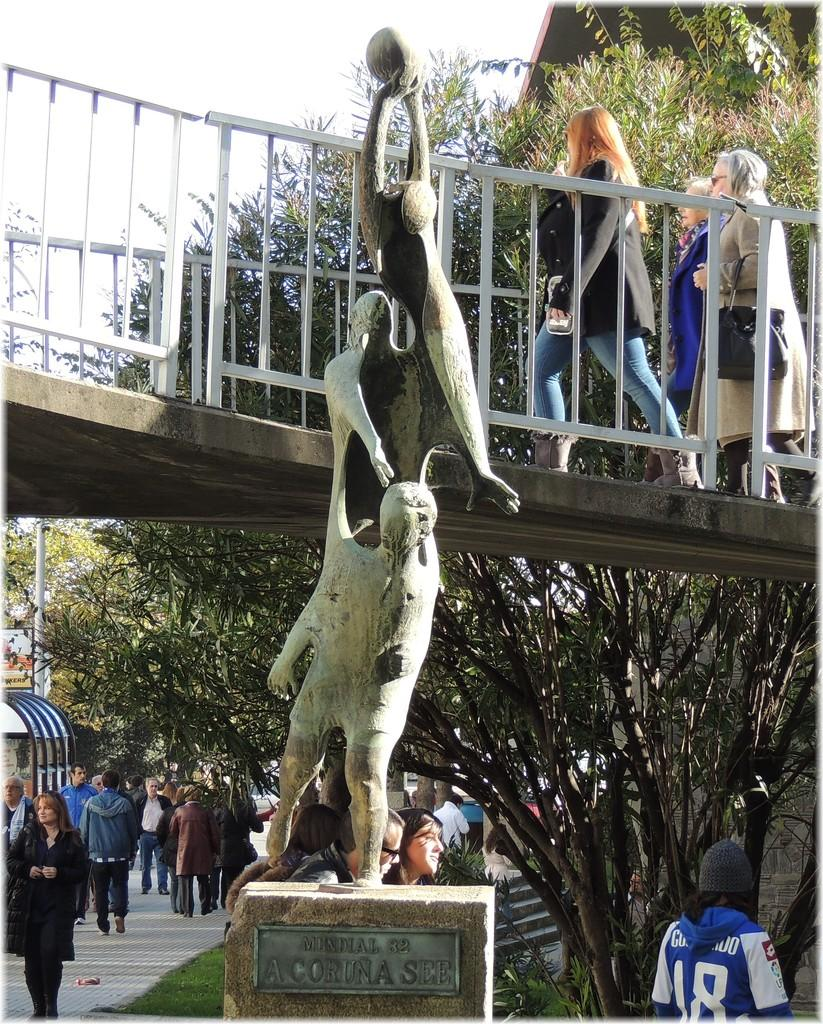<image>
Give a short and clear explanation of the subsequent image. A statue is labeled with the number 82. 